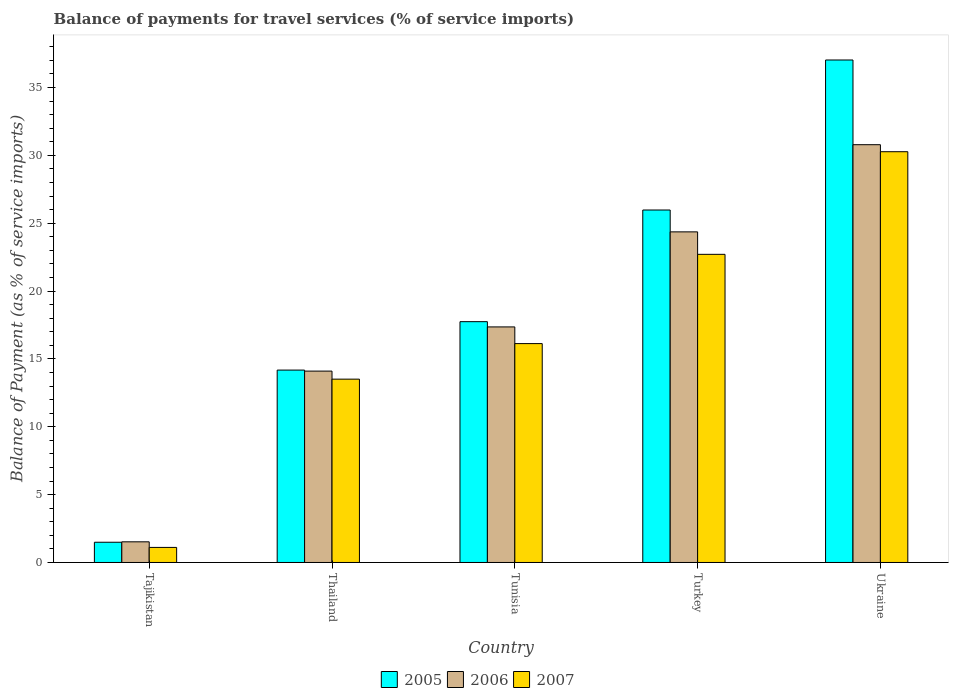How many different coloured bars are there?
Your response must be concise. 3. Are the number of bars per tick equal to the number of legend labels?
Your response must be concise. Yes. How many bars are there on the 2nd tick from the right?
Provide a short and direct response. 3. What is the label of the 5th group of bars from the left?
Your answer should be very brief. Ukraine. What is the balance of payments for travel services in 2006 in Turkey?
Provide a succinct answer. 24.36. Across all countries, what is the maximum balance of payments for travel services in 2006?
Give a very brief answer. 30.79. Across all countries, what is the minimum balance of payments for travel services in 2005?
Your response must be concise. 1.49. In which country was the balance of payments for travel services in 2006 maximum?
Your response must be concise. Ukraine. In which country was the balance of payments for travel services in 2005 minimum?
Give a very brief answer. Tajikistan. What is the total balance of payments for travel services in 2007 in the graph?
Make the answer very short. 83.73. What is the difference between the balance of payments for travel services in 2005 in Tajikistan and that in Ukraine?
Ensure brevity in your answer.  -35.54. What is the difference between the balance of payments for travel services in 2005 in Thailand and the balance of payments for travel services in 2006 in Turkey?
Provide a succinct answer. -10.19. What is the average balance of payments for travel services in 2005 per country?
Keep it short and to the point. 19.28. What is the difference between the balance of payments for travel services of/in 2007 and balance of payments for travel services of/in 2006 in Tajikistan?
Offer a very short reply. -0.41. In how many countries, is the balance of payments for travel services in 2005 greater than 34 %?
Your answer should be compact. 1. What is the ratio of the balance of payments for travel services in 2007 in Tunisia to that in Turkey?
Keep it short and to the point. 0.71. Is the difference between the balance of payments for travel services in 2007 in Thailand and Ukraine greater than the difference between the balance of payments for travel services in 2006 in Thailand and Ukraine?
Ensure brevity in your answer.  No. What is the difference between the highest and the second highest balance of payments for travel services in 2005?
Your response must be concise. -11.05. What is the difference between the highest and the lowest balance of payments for travel services in 2006?
Your response must be concise. 29.27. What does the 1st bar from the left in Tajikistan represents?
Keep it short and to the point. 2005. What does the 2nd bar from the right in Turkey represents?
Provide a short and direct response. 2006. Is it the case that in every country, the sum of the balance of payments for travel services in 2006 and balance of payments for travel services in 2007 is greater than the balance of payments for travel services in 2005?
Offer a terse response. Yes. Are all the bars in the graph horizontal?
Keep it short and to the point. No. How many countries are there in the graph?
Your response must be concise. 5. What is the difference between two consecutive major ticks on the Y-axis?
Offer a terse response. 5. Does the graph contain any zero values?
Your answer should be compact. No. Does the graph contain grids?
Keep it short and to the point. No. Where does the legend appear in the graph?
Your answer should be compact. Bottom center. What is the title of the graph?
Give a very brief answer. Balance of payments for travel services (% of service imports). What is the label or title of the X-axis?
Give a very brief answer. Country. What is the label or title of the Y-axis?
Provide a succinct answer. Balance of Payment (as % of service imports). What is the Balance of Payment (as % of service imports) in 2005 in Tajikistan?
Your answer should be compact. 1.49. What is the Balance of Payment (as % of service imports) in 2006 in Tajikistan?
Make the answer very short. 1.52. What is the Balance of Payment (as % of service imports) of 2007 in Tajikistan?
Ensure brevity in your answer.  1.11. What is the Balance of Payment (as % of service imports) of 2005 in Thailand?
Give a very brief answer. 14.18. What is the Balance of Payment (as % of service imports) of 2006 in Thailand?
Your response must be concise. 14.1. What is the Balance of Payment (as % of service imports) of 2007 in Thailand?
Keep it short and to the point. 13.51. What is the Balance of Payment (as % of service imports) in 2005 in Tunisia?
Make the answer very short. 17.75. What is the Balance of Payment (as % of service imports) in 2006 in Tunisia?
Your answer should be compact. 17.36. What is the Balance of Payment (as % of service imports) of 2007 in Tunisia?
Give a very brief answer. 16.13. What is the Balance of Payment (as % of service imports) in 2005 in Turkey?
Your response must be concise. 25.97. What is the Balance of Payment (as % of service imports) of 2006 in Turkey?
Keep it short and to the point. 24.36. What is the Balance of Payment (as % of service imports) of 2007 in Turkey?
Your answer should be very brief. 22.71. What is the Balance of Payment (as % of service imports) of 2005 in Ukraine?
Provide a succinct answer. 37.03. What is the Balance of Payment (as % of service imports) of 2006 in Ukraine?
Ensure brevity in your answer.  30.79. What is the Balance of Payment (as % of service imports) of 2007 in Ukraine?
Your response must be concise. 30.27. Across all countries, what is the maximum Balance of Payment (as % of service imports) in 2005?
Provide a succinct answer. 37.03. Across all countries, what is the maximum Balance of Payment (as % of service imports) in 2006?
Your answer should be compact. 30.79. Across all countries, what is the maximum Balance of Payment (as % of service imports) of 2007?
Keep it short and to the point. 30.27. Across all countries, what is the minimum Balance of Payment (as % of service imports) in 2005?
Offer a very short reply. 1.49. Across all countries, what is the minimum Balance of Payment (as % of service imports) in 2006?
Keep it short and to the point. 1.52. Across all countries, what is the minimum Balance of Payment (as % of service imports) in 2007?
Give a very brief answer. 1.11. What is the total Balance of Payment (as % of service imports) of 2005 in the graph?
Provide a short and direct response. 96.42. What is the total Balance of Payment (as % of service imports) in 2006 in the graph?
Your answer should be very brief. 88.14. What is the total Balance of Payment (as % of service imports) in 2007 in the graph?
Make the answer very short. 83.73. What is the difference between the Balance of Payment (as % of service imports) of 2005 in Tajikistan and that in Thailand?
Make the answer very short. -12.69. What is the difference between the Balance of Payment (as % of service imports) of 2006 in Tajikistan and that in Thailand?
Ensure brevity in your answer.  -12.58. What is the difference between the Balance of Payment (as % of service imports) of 2007 in Tajikistan and that in Thailand?
Your response must be concise. -12.4. What is the difference between the Balance of Payment (as % of service imports) in 2005 in Tajikistan and that in Tunisia?
Your response must be concise. -16.26. What is the difference between the Balance of Payment (as % of service imports) of 2006 in Tajikistan and that in Tunisia?
Offer a very short reply. -15.84. What is the difference between the Balance of Payment (as % of service imports) of 2007 in Tajikistan and that in Tunisia?
Your answer should be compact. -15.02. What is the difference between the Balance of Payment (as % of service imports) of 2005 in Tajikistan and that in Turkey?
Offer a terse response. -24.48. What is the difference between the Balance of Payment (as % of service imports) in 2006 in Tajikistan and that in Turkey?
Ensure brevity in your answer.  -22.84. What is the difference between the Balance of Payment (as % of service imports) in 2007 in Tajikistan and that in Turkey?
Offer a terse response. -21.6. What is the difference between the Balance of Payment (as % of service imports) in 2005 in Tajikistan and that in Ukraine?
Make the answer very short. -35.54. What is the difference between the Balance of Payment (as % of service imports) in 2006 in Tajikistan and that in Ukraine?
Keep it short and to the point. -29.27. What is the difference between the Balance of Payment (as % of service imports) of 2007 in Tajikistan and that in Ukraine?
Your answer should be compact. -29.16. What is the difference between the Balance of Payment (as % of service imports) in 2005 in Thailand and that in Tunisia?
Your answer should be very brief. -3.57. What is the difference between the Balance of Payment (as % of service imports) of 2006 in Thailand and that in Tunisia?
Ensure brevity in your answer.  -3.26. What is the difference between the Balance of Payment (as % of service imports) in 2007 in Thailand and that in Tunisia?
Your answer should be compact. -2.62. What is the difference between the Balance of Payment (as % of service imports) in 2005 in Thailand and that in Turkey?
Keep it short and to the point. -11.8. What is the difference between the Balance of Payment (as % of service imports) in 2006 in Thailand and that in Turkey?
Give a very brief answer. -10.26. What is the difference between the Balance of Payment (as % of service imports) in 2007 in Thailand and that in Turkey?
Provide a succinct answer. -9.2. What is the difference between the Balance of Payment (as % of service imports) of 2005 in Thailand and that in Ukraine?
Ensure brevity in your answer.  -22.85. What is the difference between the Balance of Payment (as % of service imports) in 2006 in Thailand and that in Ukraine?
Ensure brevity in your answer.  -16.68. What is the difference between the Balance of Payment (as % of service imports) of 2007 in Thailand and that in Ukraine?
Your answer should be compact. -16.76. What is the difference between the Balance of Payment (as % of service imports) of 2005 in Tunisia and that in Turkey?
Keep it short and to the point. -8.23. What is the difference between the Balance of Payment (as % of service imports) in 2006 in Tunisia and that in Turkey?
Ensure brevity in your answer.  -7.01. What is the difference between the Balance of Payment (as % of service imports) in 2007 in Tunisia and that in Turkey?
Provide a succinct answer. -6.58. What is the difference between the Balance of Payment (as % of service imports) of 2005 in Tunisia and that in Ukraine?
Provide a succinct answer. -19.28. What is the difference between the Balance of Payment (as % of service imports) in 2006 in Tunisia and that in Ukraine?
Provide a short and direct response. -13.43. What is the difference between the Balance of Payment (as % of service imports) of 2007 in Tunisia and that in Ukraine?
Your answer should be very brief. -14.14. What is the difference between the Balance of Payment (as % of service imports) in 2005 in Turkey and that in Ukraine?
Your answer should be very brief. -11.05. What is the difference between the Balance of Payment (as % of service imports) of 2006 in Turkey and that in Ukraine?
Your answer should be compact. -6.42. What is the difference between the Balance of Payment (as % of service imports) of 2007 in Turkey and that in Ukraine?
Your answer should be compact. -7.56. What is the difference between the Balance of Payment (as % of service imports) of 2005 in Tajikistan and the Balance of Payment (as % of service imports) of 2006 in Thailand?
Offer a very short reply. -12.61. What is the difference between the Balance of Payment (as % of service imports) of 2005 in Tajikistan and the Balance of Payment (as % of service imports) of 2007 in Thailand?
Your answer should be very brief. -12.02. What is the difference between the Balance of Payment (as % of service imports) in 2006 in Tajikistan and the Balance of Payment (as % of service imports) in 2007 in Thailand?
Your response must be concise. -11.99. What is the difference between the Balance of Payment (as % of service imports) of 2005 in Tajikistan and the Balance of Payment (as % of service imports) of 2006 in Tunisia?
Your answer should be compact. -15.87. What is the difference between the Balance of Payment (as % of service imports) of 2005 in Tajikistan and the Balance of Payment (as % of service imports) of 2007 in Tunisia?
Ensure brevity in your answer.  -14.64. What is the difference between the Balance of Payment (as % of service imports) of 2006 in Tajikistan and the Balance of Payment (as % of service imports) of 2007 in Tunisia?
Your answer should be compact. -14.61. What is the difference between the Balance of Payment (as % of service imports) of 2005 in Tajikistan and the Balance of Payment (as % of service imports) of 2006 in Turkey?
Offer a terse response. -22.87. What is the difference between the Balance of Payment (as % of service imports) of 2005 in Tajikistan and the Balance of Payment (as % of service imports) of 2007 in Turkey?
Your answer should be compact. -21.22. What is the difference between the Balance of Payment (as % of service imports) of 2006 in Tajikistan and the Balance of Payment (as % of service imports) of 2007 in Turkey?
Keep it short and to the point. -21.19. What is the difference between the Balance of Payment (as % of service imports) in 2005 in Tajikistan and the Balance of Payment (as % of service imports) in 2006 in Ukraine?
Keep it short and to the point. -29.3. What is the difference between the Balance of Payment (as % of service imports) of 2005 in Tajikistan and the Balance of Payment (as % of service imports) of 2007 in Ukraine?
Ensure brevity in your answer.  -28.78. What is the difference between the Balance of Payment (as % of service imports) of 2006 in Tajikistan and the Balance of Payment (as % of service imports) of 2007 in Ukraine?
Provide a short and direct response. -28.75. What is the difference between the Balance of Payment (as % of service imports) in 2005 in Thailand and the Balance of Payment (as % of service imports) in 2006 in Tunisia?
Offer a terse response. -3.18. What is the difference between the Balance of Payment (as % of service imports) of 2005 in Thailand and the Balance of Payment (as % of service imports) of 2007 in Tunisia?
Make the answer very short. -1.95. What is the difference between the Balance of Payment (as % of service imports) of 2006 in Thailand and the Balance of Payment (as % of service imports) of 2007 in Tunisia?
Offer a terse response. -2.03. What is the difference between the Balance of Payment (as % of service imports) in 2005 in Thailand and the Balance of Payment (as % of service imports) in 2006 in Turkey?
Offer a very short reply. -10.19. What is the difference between the Balance of Payment (as % of service imports) of 2005 in Thailand and the Balance of Payment (as % of service imports) of 2007 in Turkey?
Provide a succinct answer. -8.53. What is the difference between the Balance of Payment (as % of service imports) of 2006 in Thailand and the Balance of Payment (as % of service imports) of 2007 in Turkey?
Offer a terse response. -8.61. What is the difference between the Balance of Payment (as % of service imports) in 2005 in Thailand and the Balance of Payment (as % of service imports) in 2006 in Ukraine?
Your response must be concise. -16.61. What is the difference between the Balance of Payment (as % of service imports) in 2005 in Thailand and the Balance of Payment (as % of service imports) in 2007 in Ukraine?
Your answer should be compact. -16.09. What is the difference between the Balance of Payment (as % of service imports) of 2006 in Thailand and the Balance of Payment (as % of service imports) of 2007 in Ukraine?
Your answer should be compact. -16.17. What is the difference between the Balance of Payment (as % of service imports) of 2005 in Tunisia and the Balance of Payment (as % of service imports) of 2006 in Turkey?
Give a very brief answer. -6.62. What is the difference between the Balance of Payment (as % of service imports) of 2005 in Tunisia and the Balance of Payment (as % of service imports) of 2007 in Turkey?
Provide a succinct answer. -4.96. What is the difference between the Balance of Payment (as % of service imports) of 2006 in Tunisia and the Balance of Payment (as % of service imports) of 2007 in Turkey?
Provide a short and direct response. -5.35. What is the difference between the Balance of Payment (as % of service imports) of 2005 in Tunisia and the Balance of Payment (as % of service imports) of 2006 in Ukraine?
Keep it short and to the point. -13.04. What is the difference between the Balance of Payment (as % of service imports) of 2005 in Tunisia and the Balance of Payment (as % of service imports) of 2007 in Ukraine?
Give a very brief answer. -12.53. What is the difference between the Balance of Payment (as % of service imports) in 2006 in Tunisia and the Balance of Payment (as % of service imports) in 2007 in Ukraine?
Make the answer very short. -12.91. What is the difference between the Balance of Payment (as % of service imports) of 2005 in Turkey and the Balance of Payment (as % of service imports) of 2006 in Ukraine?
Offer a very short reply. -4.81. What is the difference between the Balance of Payment (as % of service imports) of 2005 in Turkey and the Balance of Payment (as % of service imports) of 2007 in Ukraine?
Ensure brevity in your answer.  -4.3. What is the difference between the Balance of Payment (as % of service imports) in 2006 in Turkey and the Balance of Payment (as % of service imports) in 2007 in Ukraine?
Make the answer very short. -5.91. What is the average Balance of Payment (as % of service imports) in 2005 per country?
Your answer should be compact. 19.28. What is the average Balance of Payment (as % of service imports) in 2006 per country?
Your answer should be very brief. 17.63. What is the average Balance of Payment (as % of service imports) in 2007 per country?
Offer a terse response. 16.75. What is the difference between the Balance of Payment (as % of service imports) in 2005 and Balance of Payment (as % of service imports) in 2006 in Tajikistan?
Offer a very short reply. -0.03. What is the difference between the Balance of Payment (as % of service imports) in 2005 and Balance of Payment (as % of service imports) in 2007 in Tajikistan?
Provide a short and direct response. 0.38. What is the difference between the Balance of Payment (as % of service imports) in 2006 and Balance of Payment (as % of service imports) in 2007 in Tajikistan?
Offer a terse response. 0.41. What is the difference between the Balance of Payment (as % of service imports) in 2005 and Balance of Payment (as % of service imports) in 2006 in Thailand?
Your answer should be compact. 0.08. What is the difference between the Balance of Payment (as % of service imports) of 2005 and Balance of Payment (as % of service imports) of 2007 in Thailand?
Keep it short and to the point. 0.67. What is the difference between the Balance of Payment (as % of service imports) of 2006 and Balance of Payment (as % of service imports) of 2007 in Thailand?
Offer a terse response. 0.59. What is the difference between the Balance of Payment (as % of service imports) of 2005 and Balance of Payment (as % of service imports) of 2006 in Tunisia?
Offer a terse response. 0.39. What is the difference between the Balance of Payment (as % of service imports) in 2005 and Balance of Payment (as % of service imports) in 2007 in Tunisia?
Provide a succinct answer. 1.62. What is the difference between the Balance of Payment (as % of service imports) in 2006 and Balance of Payment (as % of service imports) in 2007 in Tunisia?
Your answer should be very brief. 1.23. What is the difference between the Balance of Payment (as % of service imports) in 2005 and Balance of Payment (as % of service imports) in 2006 in Turkey?
Give a very brief answer. 1.61. What is the difference between the Balance of Payment (as % of service imports) in 2005 and Balance of Payment (as % of service imports) in 2007 in Turkey?
Your answer should be very brief. 3.27. What is the difference between the Balance of Payment (as % of service imports) in 2006 and Balance of Payment (as % of service imports) in 2007 in Turkey?
Give a very brief answer. 1.66. What is the difference between the Balance of Payment (as % of service imports) of 2005 and Balance of Payment (as % of service imports) of 2006 in Ukraine?
Give a very brief answer. 6.24. What is the difference between the Balance of Payment (as % of service imports) in 2005 and Balance of Payment (as % of service imports) in 2007 in Ukraine?
Your answer should be compact. 6.76. What is the difference between the Balance of Payment (as % of service imports) of 2006 and Balance of Payment (as % of service imports) of 2007 in Ukraine?
Ensure brevity in your answer.  0.52. What is the ratio of the Balance of Payment (as % of service imports) in 2005 in Tajikistan to that in Thailand?
Your answer should be compact. 0.11. What is the ratio of the Balance of Payment (as % of service imports) of 2006 in Tajikistan to that in Thailand?
Offer a terse response. 0.11. What is the ratio of the Balance of Payment (as % of service imports) of 2007 in Tajikistan to that in Thailand?
Ensure brevity in your answer.  0.08. What is the ratio of the Balance of Payment (as % of service imports) of 2005 in Tajikistan to that in Tunisia?
Offer a terse response. 0.08. What is the ratio of the Balance of Payment (as % of service imports) of 2006 in Tajikistan to that in Tunisia?
Offer a terse response. 0.09. What is the ratio of the Balance of Payment (as % of service imports) of 2007 in Tajikistan to that in Tunisia?
Provide a short and direct response. 0.07. What is the ratio of the Balance of Payment (as % of service imports) of 2005 in Tajikistan to that in Turkey?
Make the answer very short. 0.06. What is the ratio of the Balance of Payment (as % of service imports) in 2006 in Tajikistan to that in Turkey?
Make the answer very short. 0.06. What is the ratio of the Balance of Payment (as % of service imports) in 2007 in Tajikistan to that in Turkey?
Provide a succinct answer. 0.05. What is the ratio of the Balance of Payment (as % of service imports) of 2005 in Tajikistan to that in Ukraine?
Your answer should be compact. 0.04. What is the ratio of the Balance of Payment (as % of service imports) in 2006 in Tajikistan to that in Ukraine?
Provide a short and direct response. 0.05. What is the ratio of the Balance of Payment (as % of service imports) of 2007 in Tajikistan to that in Ukraine?
Provide a succinct answer. 0.04. What is the ratio of the Balance of Payment (as % of service imports) of 2005 in Thailand to that in Tunisia?
Give a very brief answer. 0.8. What is the ratio of the Balance of Payment (as % of service imports) in 2006 in Thailand to that in Tunisia?
Keep it short and to the point. 0.81. What is the ratio of the Balance of Payment (as % of service imports) of 2007 in Thailand to that in Tunisia?
Your answer should be compact. 0.84. What is the ratio of the Balance of Payment (as % of service imports) in 2005 in Thailand to that in Turkey?
Give a very brief answer. 0.55. What is the ratio of the Balance of Payment (as % of service imports) of 2006 in Thailand to that in Turkey?
Provide a succinct answer. 0.58. What is the ratio of the Balance of Payment (as % of service imports) in 2007 in Thailand to that in Turkey?
Your response must be concise. 0.59. What is the ratio of the Balance of Payment (as % of service imports) in 2005 in Thailand to that in Ukraine?
Offer a terse response. 0.38. What is the ratio of the Balance of Payment (as % of service imports) of 2006 in Thailand to that in Ukraine?
Your answer should be very brief. 0.46. What is the ratio of the Balance of Payment (as % of service imports) in 2007 in Thailand to that in Ukraine?
Keep it short and to the point. 0.45. What is the ratio of the Balance of Payment (as % of service imports) of 2005 in Tunisia to that in Turkey?
Your answer should be compact. 0.68. What is the ratio of the Balance of Payment (as % of service imports) in 2006 in Tunisia to that in Turkey?
Offer a very short reply. 0.71. What is the ratio of the Balance of Payment (as % of service imports) of 2007 in Tunisia to that in Turkey?
Provide a succinct answer. 0.71. What is the ratio of the Balance of Payment (as % of service imports) in 2005 in Tunisia to that in Ukraine?
Provide a short and direct response. 0.48. What is the ratio of the Balance of Payment (as % of service imports) in 2006 in Tunisia to that in Ukraine?
Ensure brevity in your answer.  0.56. What is the ratio of the Balance of Payment (as % of service imports) of 2007 in Tunisia to that in Ukraine?
Your answer should be compact. 0.53. What is the ratio of the Balance of Payment (as % of service imports) of 2005 in Turkey to that in Ukraine?
Keep it short and to the point. 0.7. What is the ratio of the Balance of Payment (as % of service imports) of 2006 in Turkey to that in Ukraine?
Your answer should be compact. 0.79. What is the ratio of the Balance of Payment (as % of service imports) in 2007 in Turkey to that in Ukraine?
Give a very brief answer. 0.75. What is the difference between the highest and the second highest Balance of Payment (as % of service imports) in 2005?
Provide a succinct answer. 11.05. What is the difference between the highest and the second highest Balance of Payment (as % of service imports) of 2006?
Provide a short and direct response. 6.42. What is the difference between the highest and the second highest Balance of Payment (as % of service imports) in 2007?
Your answer should be very brief. 7.56. What is the difference between the highest and the lowest Balance of Payment (as % of service imports) of 2005?
Your answer should be compact. 35.54. What is the difference between the highest and the lowest Balance of Payment (as % of service imports) of 2006?
Provide a succinct answer. 29.27. What is the difference between the highest and the lowest Balance of Payment (as % of service imports) of 2007?
Offer a terse response. 29.16. 